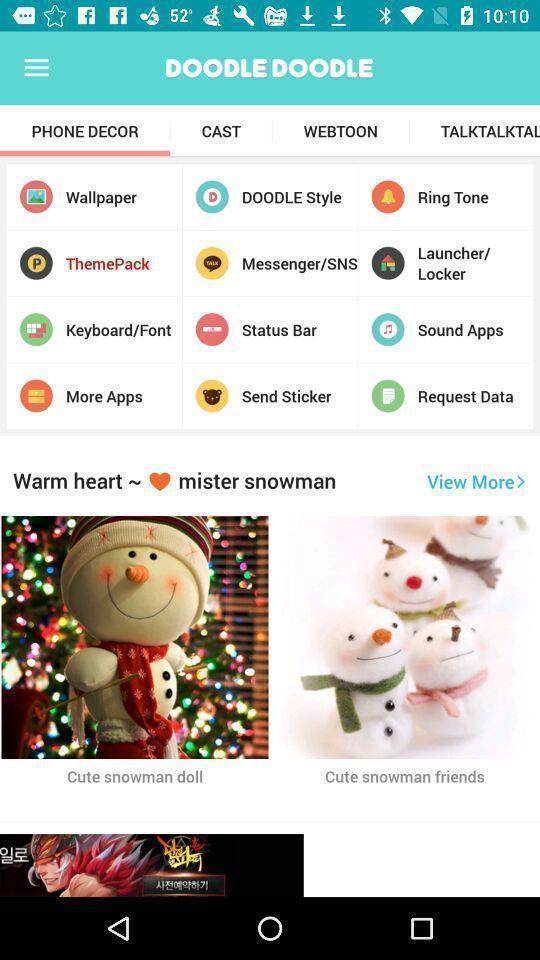Describe the content in this image. Page showing phone decor with theme park selected in application. 